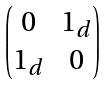Convert formula to latex. <formula><loc_0><loc_0><loc_500><loc_500>\begin{pmatrix} 0 & 1 _ { d } \\ 1 _ { d } & 0 \end{pmatrix}</formula> 